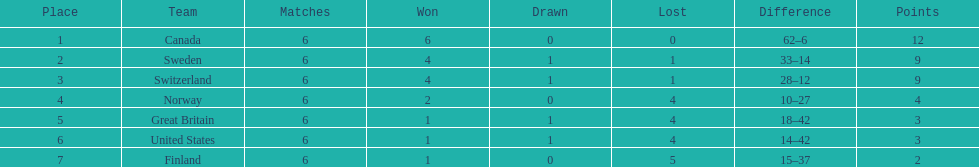How many teams emerged victorious in 6 games? 1. 